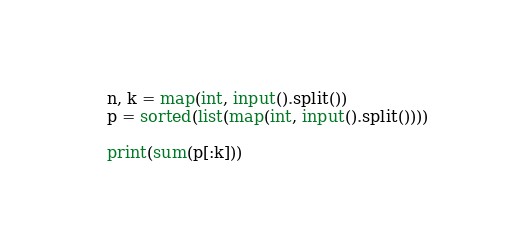<code> <loc_0><loc_0><loc_500><loc_500><_Python_>n, k = map(int, input().split())
p = sorted(list(map(int, input().split())))

print(sum(p[:k]))
</code> 